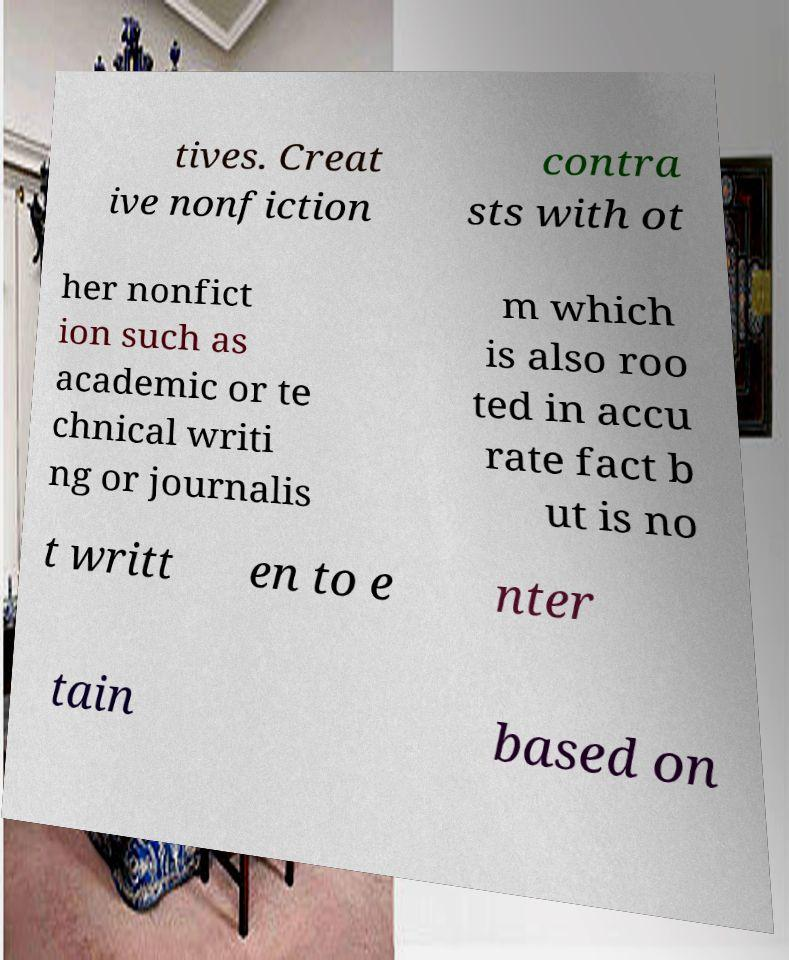I need the written content from this picture converted into text. Can you do that? tives. Creat ive nonfiction contra sts with ot her nonfict ion such as academic or te chnical writi ng or journalis m which is also roo ted in accu rate fact b ut is no t writt en to e nter tain based on 